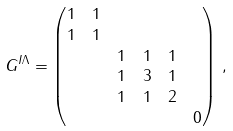Convert formula to latex. <formula><loc_0><loc_0><loc_500><loc_500>G ^ { I \Lambda } & = \begin{pmatrix} 1 & 1 & & & & \\ 1 & 1 & & & & \\ & & 1 & 1 & 1 & \\ & & 1 & 3 & 1 \\ & & 1 & 1 & 2 & \\ & & & & & 0 \\ \end{pmatrix} \, ,</formula> 